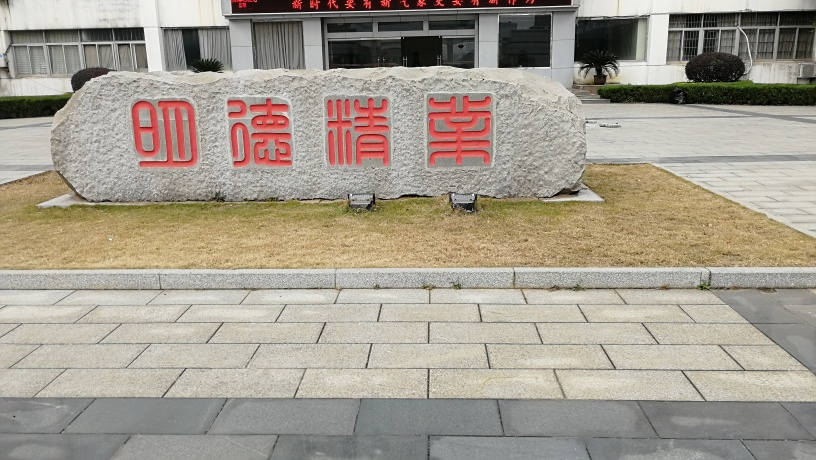What is the lighting like in the image?
 Ample 